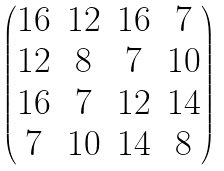<formula> <loc_0><loc_0><loc_500><loc_500>\begin{pmatrix} 1 6 & 1 2 & 1 6 & 7 \\ 1 2 & 8 & 7 & 1 0 \\ 1 6 & 7 & 1 2 & 1 4 \\ 7 & 1 0 & 1 4 & 8 \\ \end{pmatrix}</formula> 